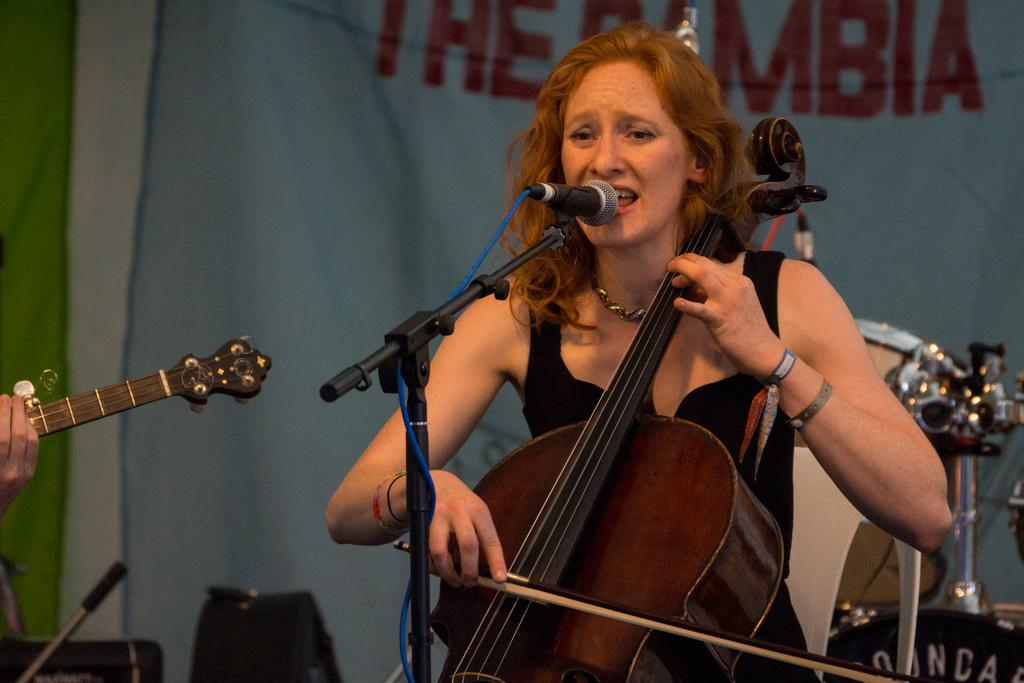Who is the main subject in the image? There is a woman in the image. What is the woman doing in the image? The woman is playing a violin. What is in front of her in the image? There is a microphone and a microphone stand in front of her. What is the woman wearing in the image? The woman is wearing a black dress. What can be seen in the background of the image? There is a banner and a band in the background of the image. What is the plot of the battle depicted in the image? There is no battle depicted in the image, so it's not possible to determine the plot. 